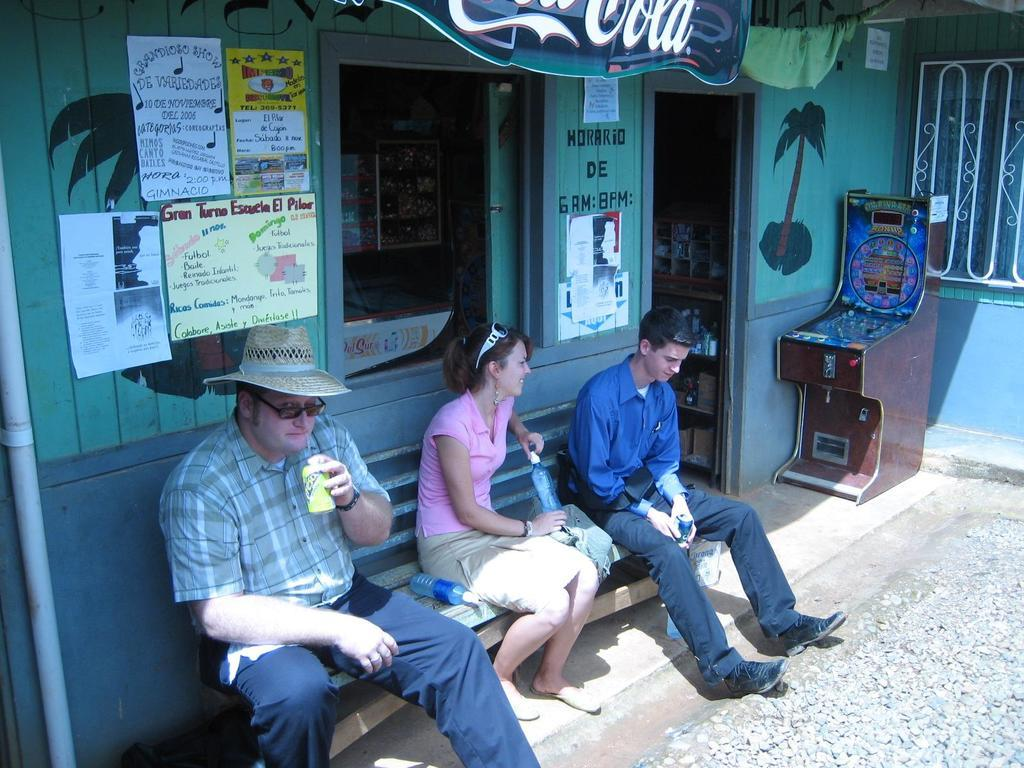How many people are in the image? There are two men and a woman in the image, making a total of three people. What are the people in the image doing? They are sitting on a bench. What objects can be seen in the image besides the people? There are stones, bottles, posters, a window, and a pipe visible in the image. What can be seen in the background of the image? There are objects visible in the background of the image. What type of feast is being prepared in the image? There is no indication of a feast or any food preparation in the image. How many groups of people are present in the image? There is only one group of people in the image, consisting of two men and a woman. 